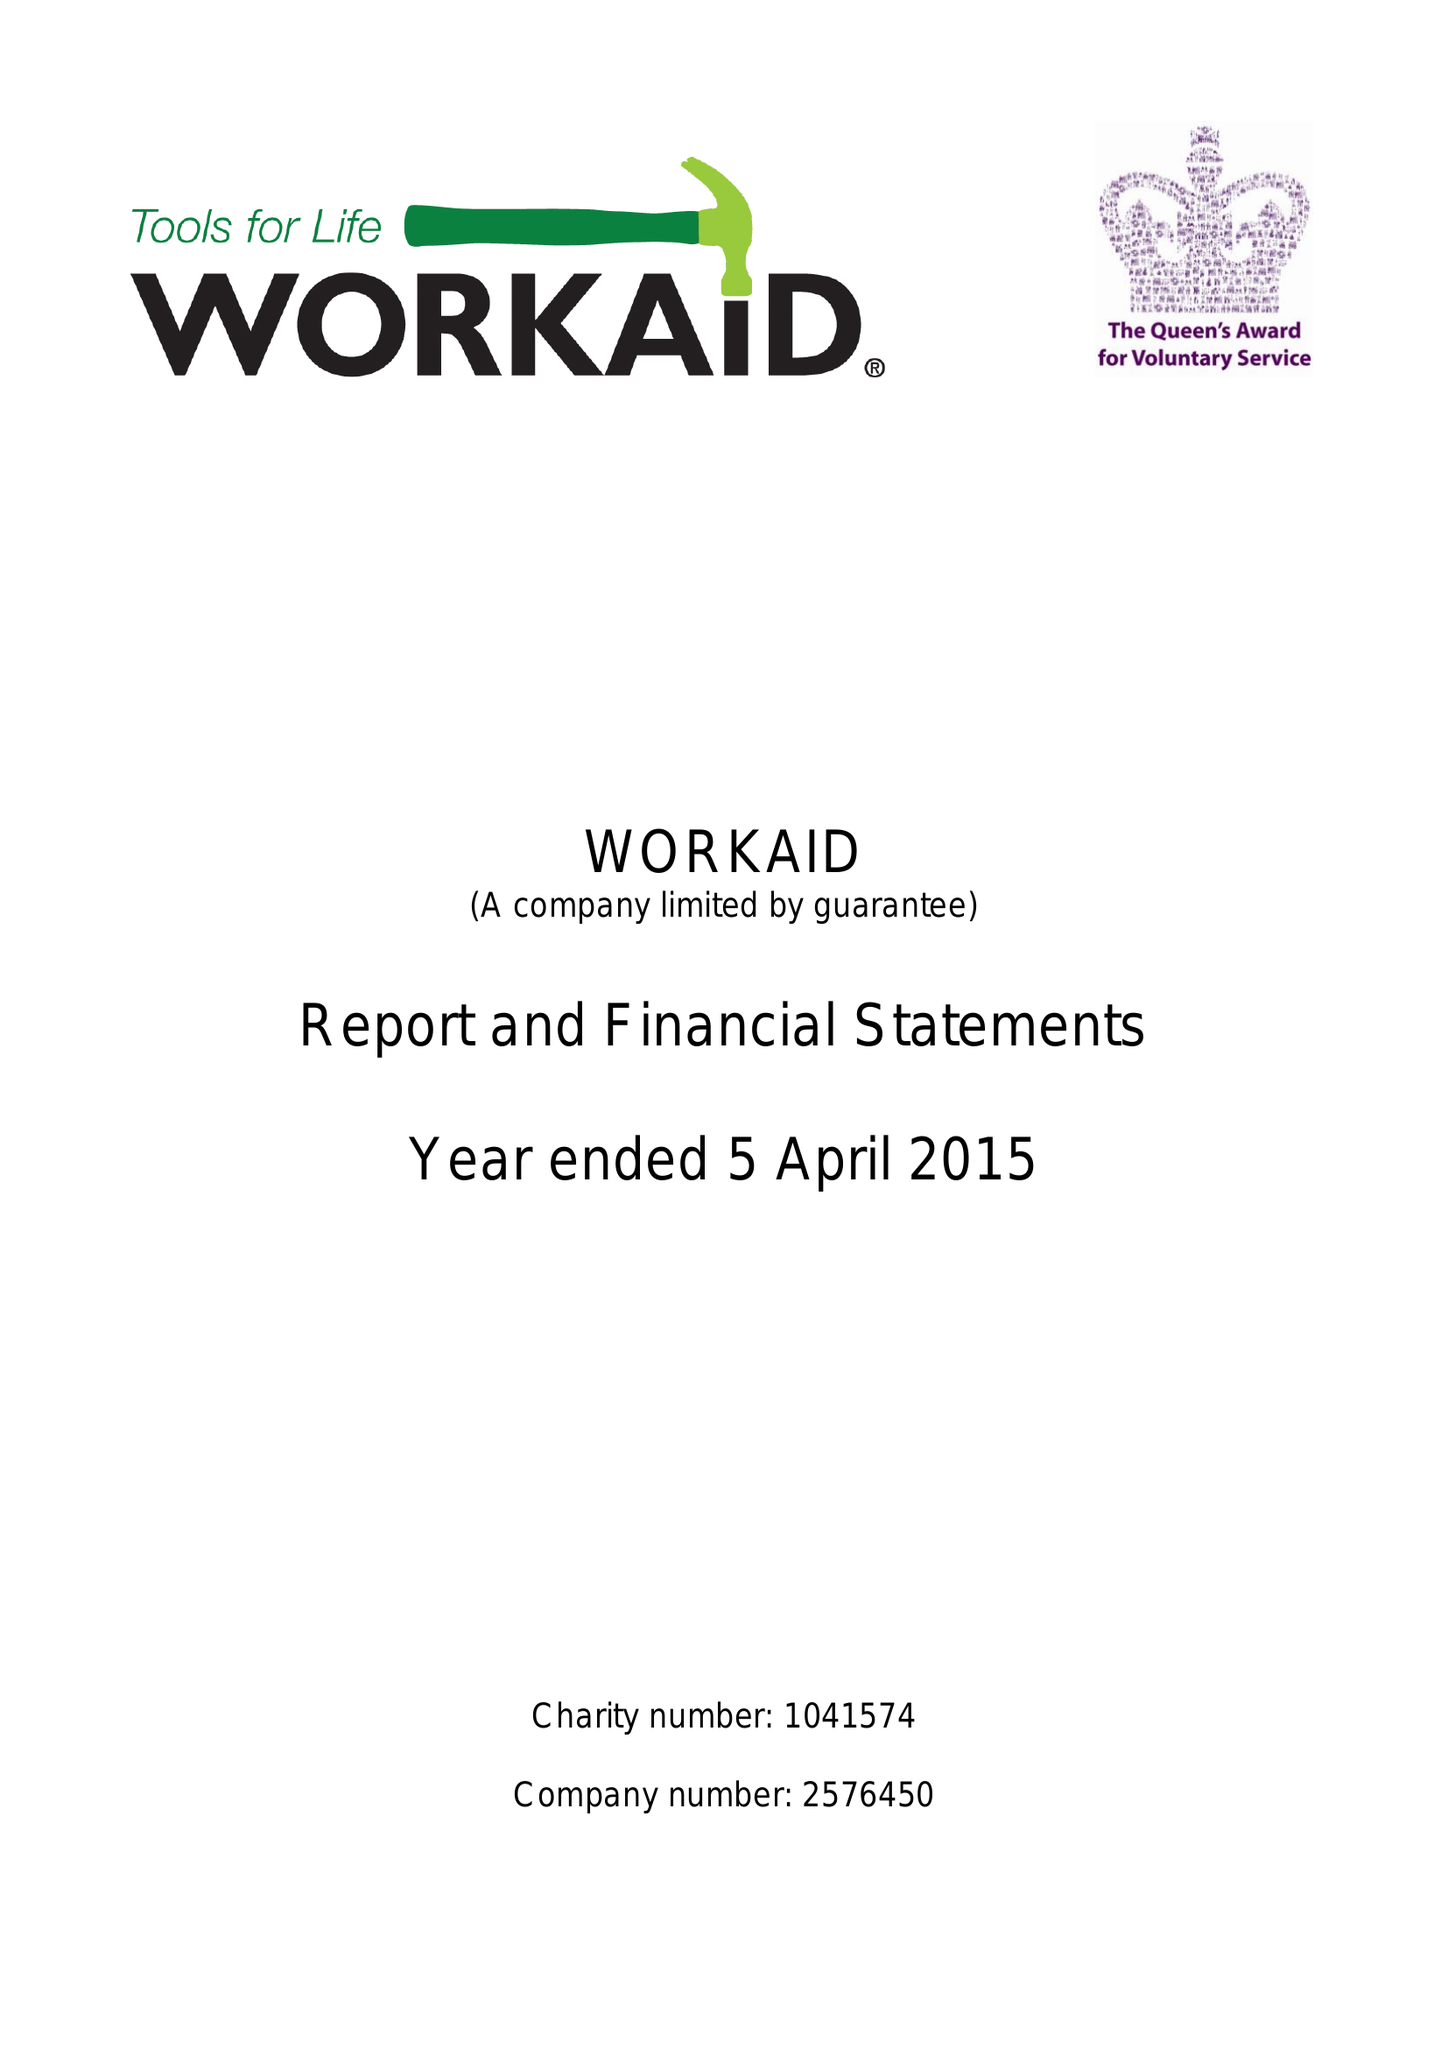What is the value for the spending_annually_in_british_pounds?
Answer the question using a single word or phrase. 206432.00 